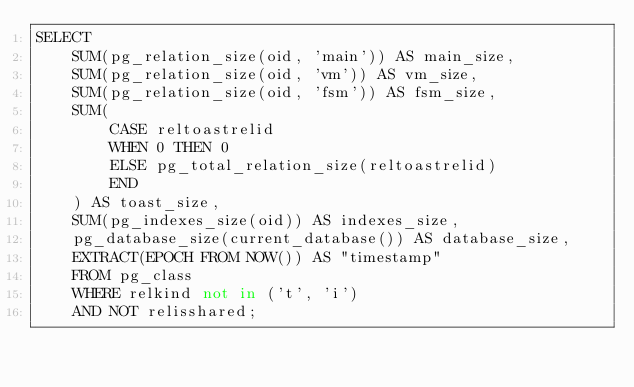Convert code to text. <code><loc_0><loc_0><loc_500><loc_500><_SQL_>SELECT
    SUM(pg_relation_size(oid, 'main')) AS main_size,
    SUM(pg_relation_size(oid, 'vm')) AS vm_size,
    SUM(pg_relation_size(oid, 'fsm')) AS fsm_size,
    SUM(
        CASE reltoastrelid
        WHEN 0 THEN 0
        ELSE pg_total_relation_size(reltoastrelid)
        END
    ) AS toast_size,
    SUM(pg_indexes_size(oid)) AS indexes_size,
    pg_database_size(current_database()) AS database_size,
    EXTRACT(EPOCH FROM NOW()) AS "timestamp"
    FROM pg_class
    WHERE relkind not in ('t', 'i')
    AND NOT relisshared;
</code> 